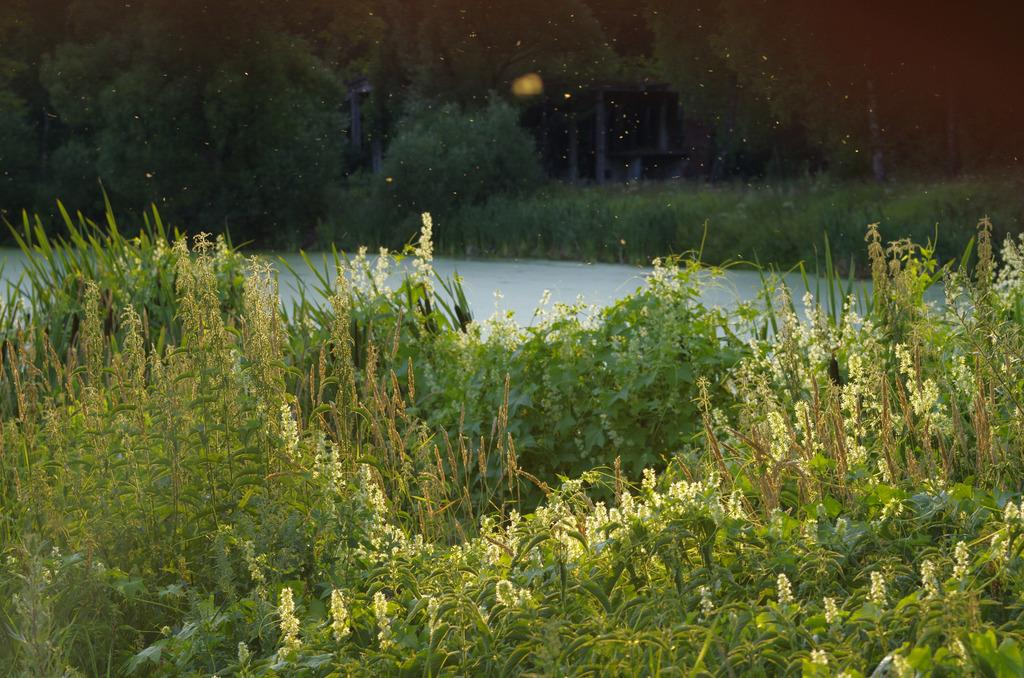What type of vegetation can be seen in the image? There are green color plants and trees in the image. What natural element is visible in the image? There is water visible in the image. What is the color of the object in the image? The object in the image is black in color. What type of quiver can be seen in the image? There is no quiver present in the image. How does the society depicted in the image contribute to the overall scene? There is no society depicted in the image, as it features plants, trees, water, and a black object. 